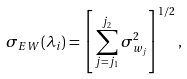Convert formula to latex. <formula><loc_0><loc_0><loc_500><loc_500>\sigma _ { E W } ( \lambda _ { i } ) = \left [ \, \sum _ { j = j _ { 1 } } ^ { j _ { 2 } } \sigma ^ { 2 } _ { w _ { j } } \right ] ^ { 1 / 2 } ,</formula> 